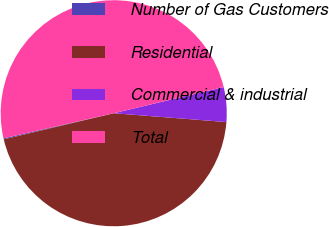<chart> <loc_0><loc_0><loc_500><loc_500><pie_chart><fcel>Number of Gas Customers<fcel>Residential<fcel>Commercial & industrial<fcel>Total<nl><fcel>0.15%<fcel>45.04%<fcel>4.96%<fcel>49.85%<nl></chart> 